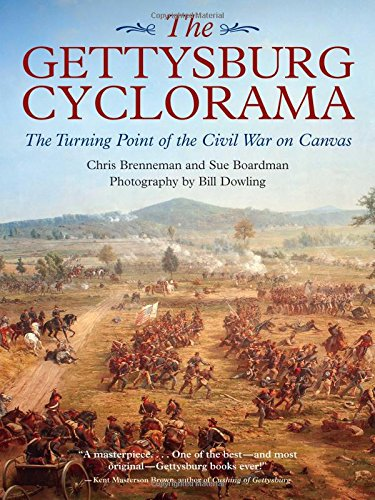What is the genre of this book? The genre of this book is history. It provides a detailed recount of a pivotal Civil War battle, delving into the historical context and impact, all illustrated through photographs of the renowned Gettysburg Cyclorama. 